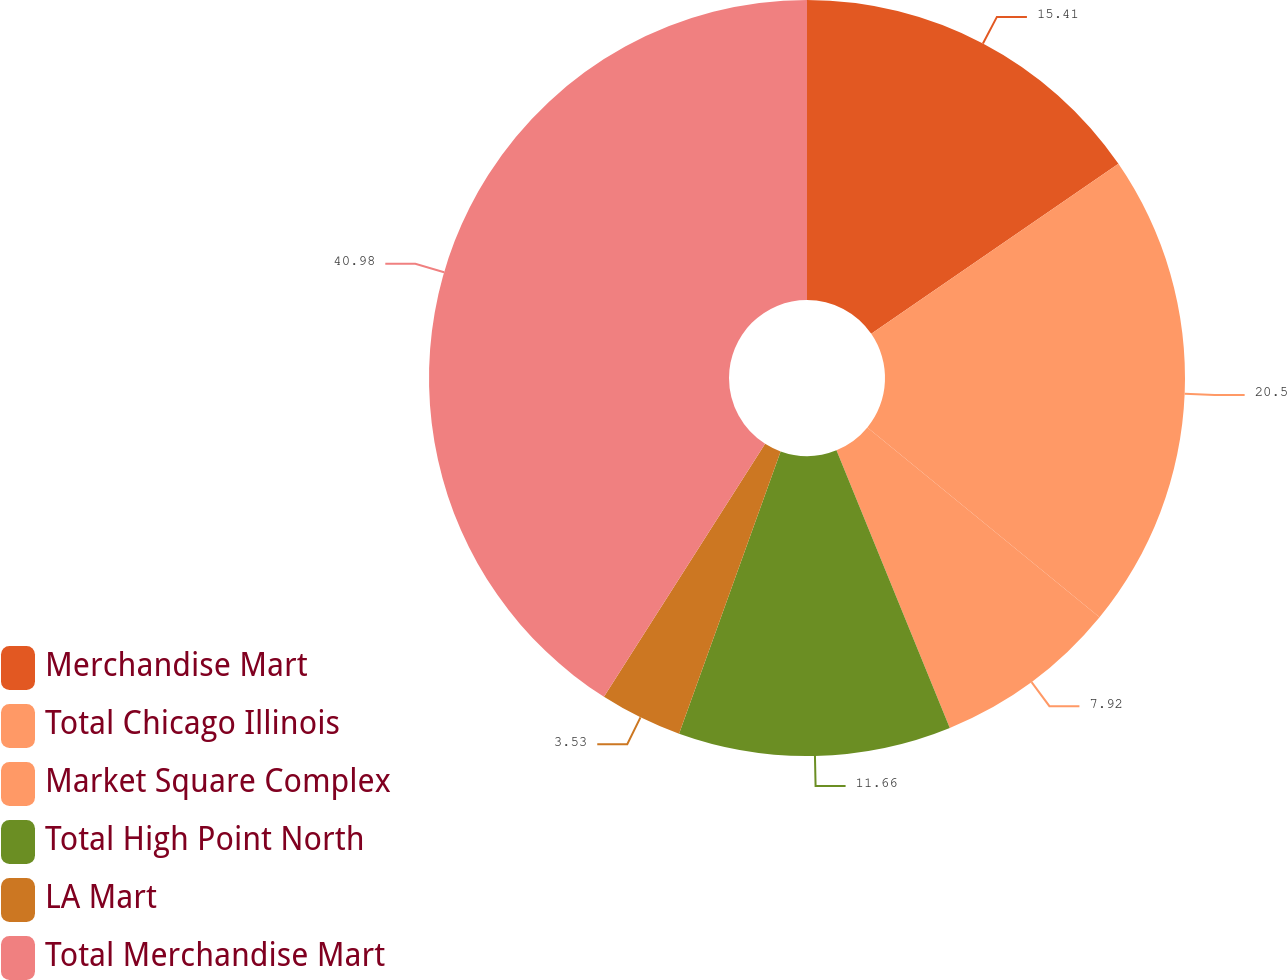<chart> <loc_0><loc_0><loc_500><loc_500><pie_chart><fcel>Merchandise Mart<fcel>Total Chicago Illinois<fcel>Market Square Complex<fcel>Total High Point North<fcel>LA Mart<fcel>Total Merchandise Mart<nl><fcel>15.41%<fcel>20.5%<fcel>7.92%<fcel>11.66%<fcel>3.53%<fcel>40.97%<nl></chart> 